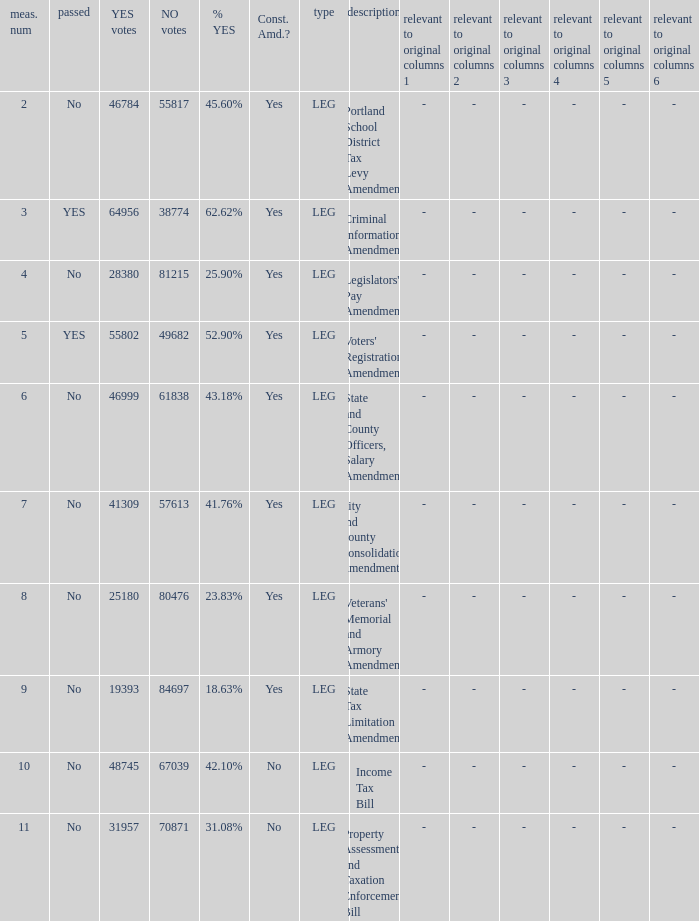Who had 41.76% yes votes City and County Consolidation Amendment. 